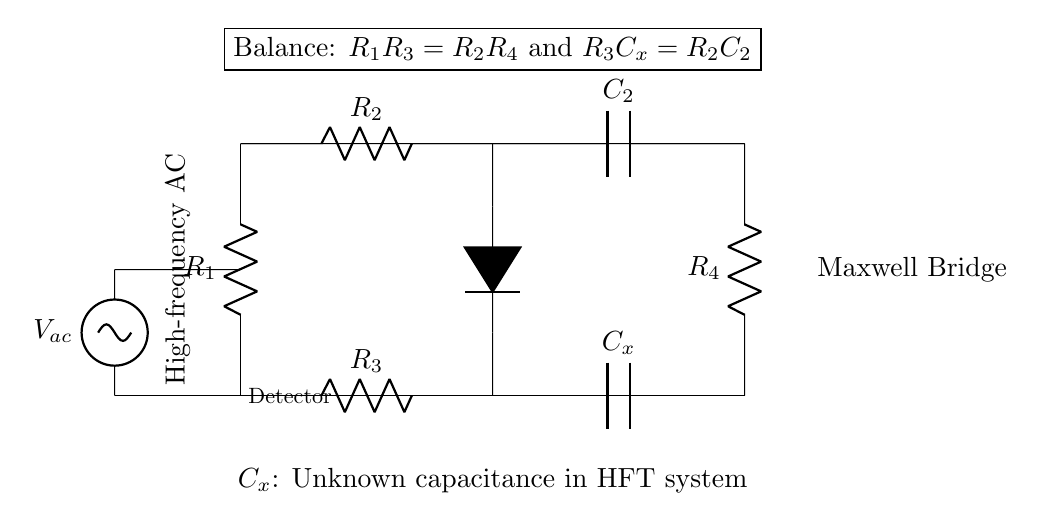What type of circuit is this? This circuit is a Maxwell Bridge, which is used to measure unknown capacitance by balancing the bridge in an AC circuit configuration.
Answer: Maxwell Bridge How many resistors are in the circuit? The circuit contains four resistors, which are labeled as R1, R2, R3, and R4.
Answer: Four What is the balance condition mentioned in the circuit? The balance condition shows two equations: R1R3 = R2R4 and R3Cx = R2C2, indicating how the resistors and capacitance relate to balance the bridge.
Answer: R1R3 = R2R4 and R3Cx = R2C2 What is the function of the detector in the circuit? The detector measures the current or voltage difference between the two arms of the bridge when it is balanced, helping to ensure accurate capacitance measurements.
Answer: Measure Which component represents the unknown capacitance? The component representing the unknown capacitance is labeled Cx in the circuit diagram.
Answer: Cx What is the nature of the AC source used in this circuit? The nature of the AC source is sinusoidal, as indicated by the label next to the voltage source.
Answer: Sinusoidal What is the purpose of using the Maxwell Bridge in high-frequency trading systems? The Maxwell Bridge is used to analyze capacitive components which can affect the performance of high-frequency trading systems, allowing for precise measurement of capacitance.
Answer: Analyze capacitance 